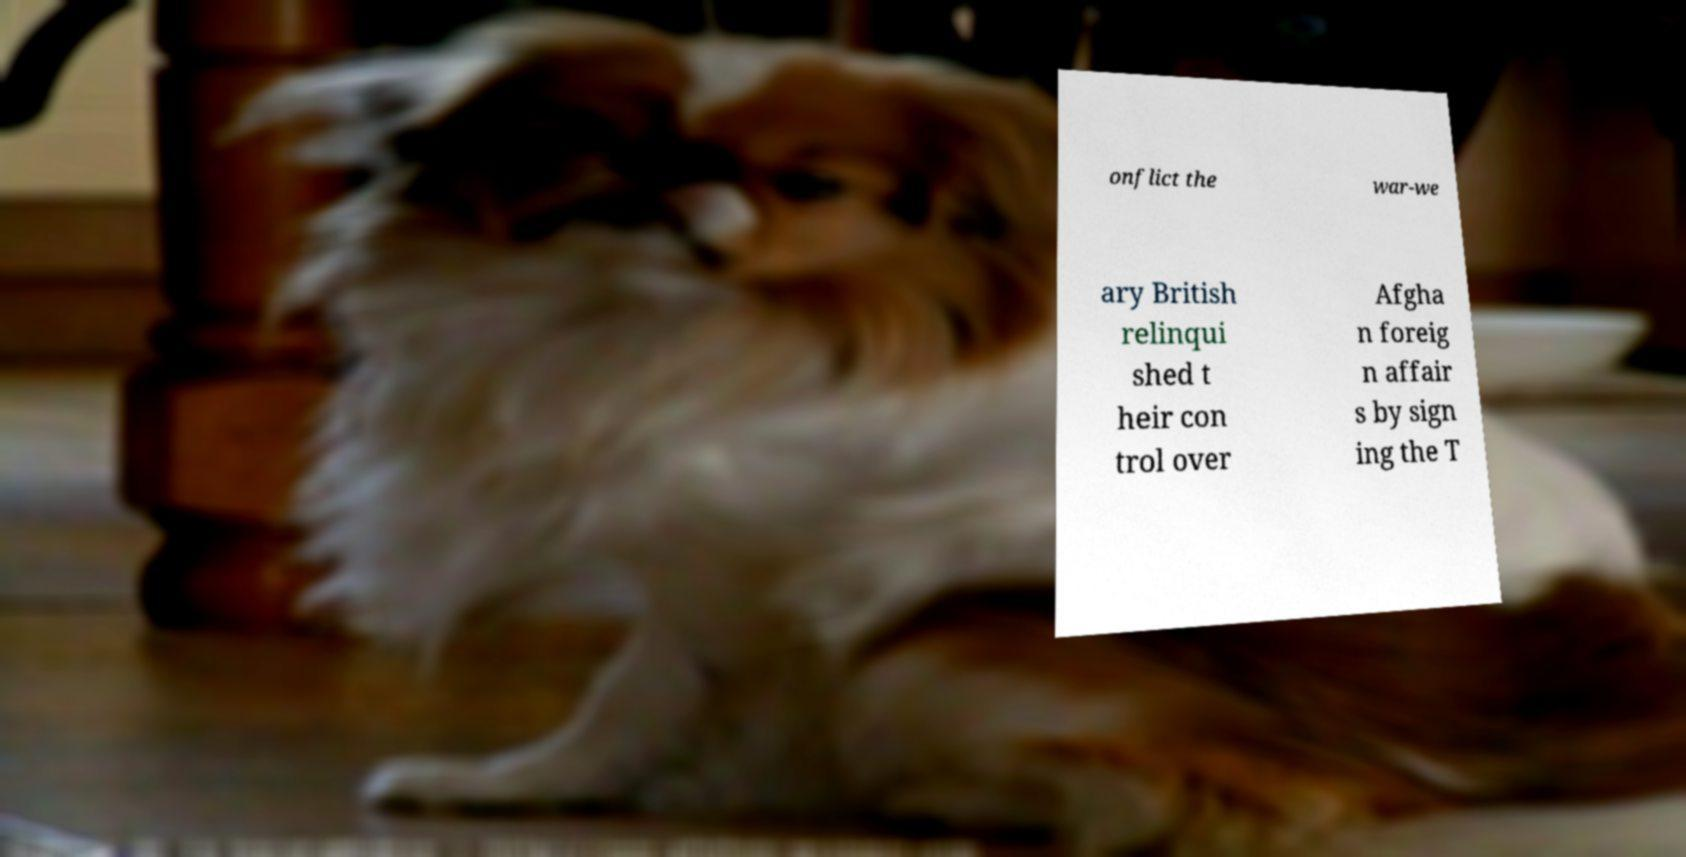What messages or text are displayed in this image? I need them in a readable, typed format. onflict the war-we ary British relinqui shed t heir con trol over Afgha n foreig n affair s by sign ing the T 